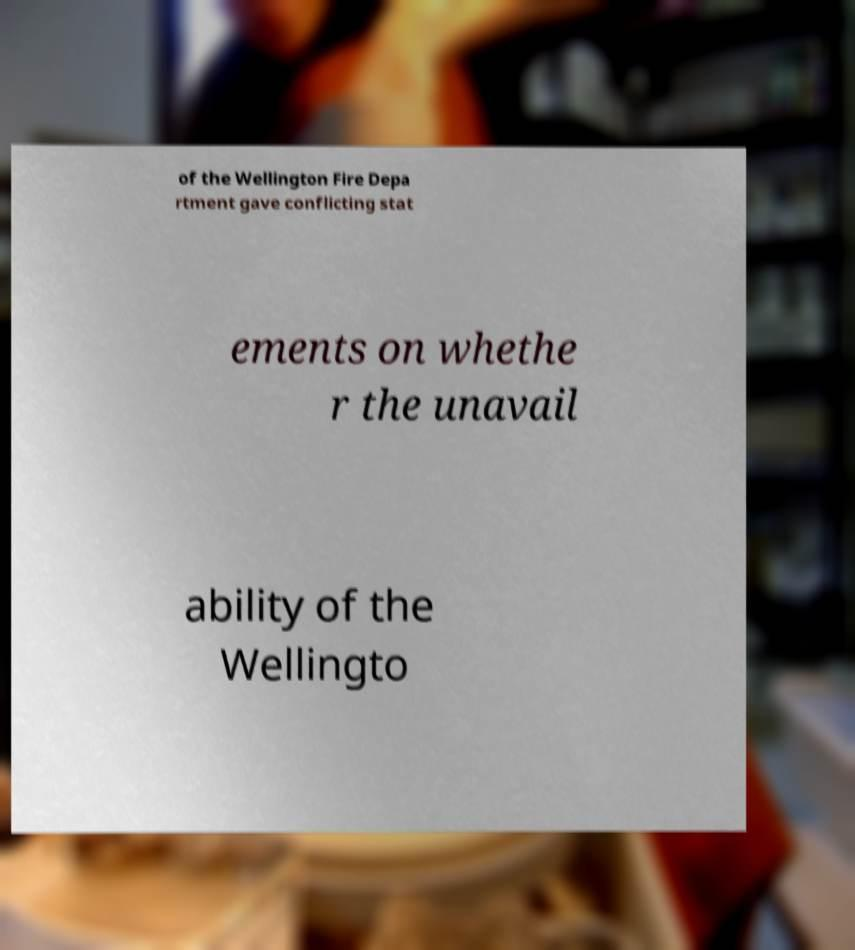Can you accurately transcribe the text from the provided image for me? of the Wellington Fire Depa rtment gave conflicting stat ements on whethe r the unavail ability of the Wellingto 